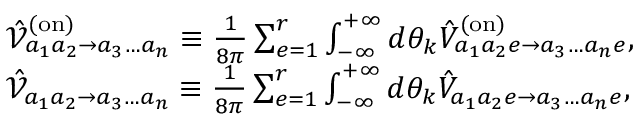<formula> <loc_0><loc_0><loc_500><loc_500>\begin{array} { r l } & { \hat { \mathcal { V } } _ { a _ { 1 } a _ { 2 } \to a _ { 3 } \dots a _ { n } } ^ { ( o n ) } \equiv \frac { 1 } { 8 \pi } \sum _ { e = 1 } ^ { r } \int _ { - \infty } ^ { + \infty } d \theta _ { k } \hat { V } _ { a _ { 1 } a _ { 2 } e \to a _ { 3 } \dots a _ { n } e } ^ { ( o n ) } , } \\ & { \hat { \mathcal { V } } _ { a _ { 1 } a _ { 2 } \to a _ { 3 } \dots a _ { n } } \equiv \frac { 1 } { 8 \pi } \sum _ { e = 1 } ^ { r } \int _ { - \infty } ^ { + \infty } d \theta _ { k } \hat { V } _ { a _ { 1 } a _ { 2 } e \to a _ { 3 } \dots a _ { n } e } , } \end{array}</formula> 